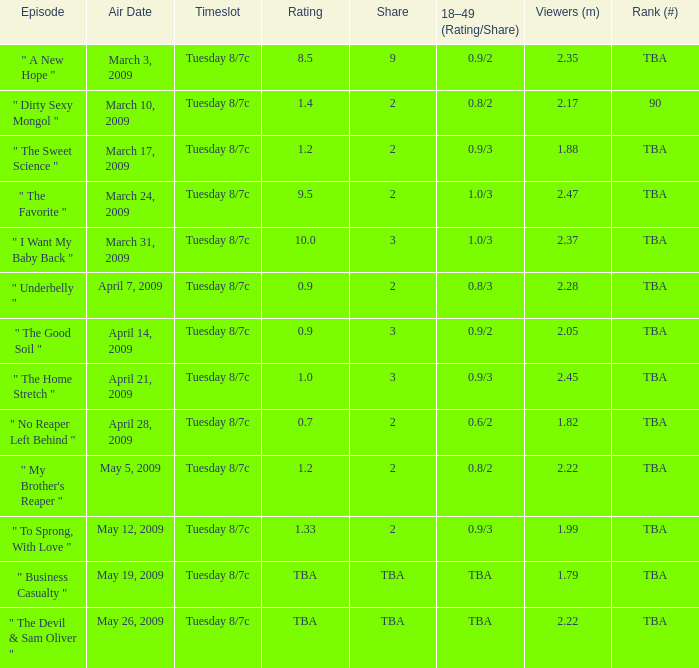8/3? 2.0. 